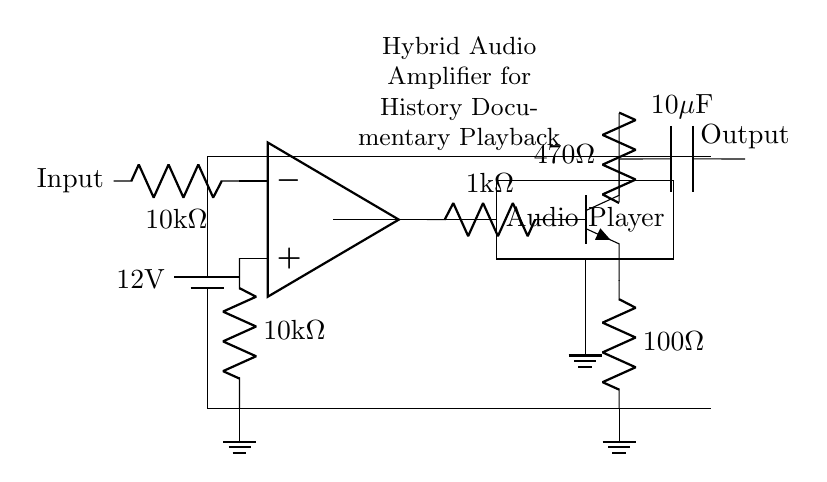What is the power supply voltage? The power supply voltage is indicated next to the battery symbol at the top of the circuit diagram, where it states "12V".
Answer: 12V What type of amplifier is represented in this circuit? The circuit specifically refers to a hybrid audio amplifier designed for playback. This is evident from the label in the diagram and the combination of components used.
Answer: Hybrid audio amplifier How many resistors are used in this circuit? By counting the resistors in the circuit diagram, which are marked with the resistor symbol, there are four resistors present.
Answer: Four What is the capacitance value in the output stage? The capacitance value is provided next to the capacitor symbol in the output stage, where it is specified as "10 microfarads".
Answer: 10 microfarads What type of transistor is depicted in the circuit? The transistor shown is an NPN type, which is denoted by the symbol and the specific node markers in the diagram identifying it as Q1.
Answer: NPN What is the function of the input stage resistor? The input stage resistor is used to limit current entering the op-amp, helping control the gain and protect the op-amp from excessive current. This is common practice in amplifier design.
Answer: Limit current Where does the audio signal input connect? The audio signal input connects to the left side of the first resistor labeled as "10k ohms" in the input stage. This connection is essential for signal processing within the op-amp.
Answer: Input terminal 